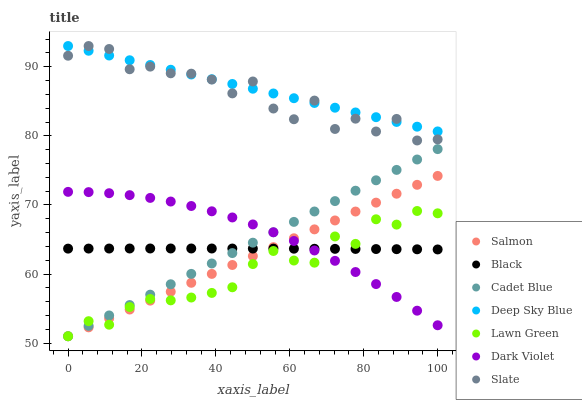Does Lawn Green have the minimum area under the curve?
Answer yes or no. Yes. Does Deep Sky Blue have the maximum area under the curve?
Answer yes or no. Yes. Does Cadet Blue have the minimum area under the curve?
Answer yes or no. No. Does Cadet Blue have the maximum area under the curve?
Answer yes or no. No. Is Deep Sky Blue the smoothest?
Answer yes or no. Yes. Is Slate the roughest?
Answer yes or no. Yes. Is Cadet Blue the smoothest?
Answer yes or no. No. Is Cadet Blue the roughest?
Answer yes or no. No. Does Lawn Green have the lowest value?
Answer yes or no. Yes. Does Slate have the lowest value?
Answer yes or no. No. Does Deep Sky Blue have the highest value?
Answer yes or no. Yes. Does Cadet Blue have the highest value?
Answer yes or no. No. Is Lawn Green less than Slate?
Answer yes or no. Yes. Is Deep Sky Blue greater than Salmon?
Answer yes or no. Yes. Does Lawn Green intersect Dark Violet?
Answer yes or no. Yes. Is Lawn Green less than Dark Violet?
Answer yes or no. No. Is Lawn Green greater than Dark Violet?
Answer yes or no. No. Does Lawn Green intersect Slate?
Answer yes or no. No. 